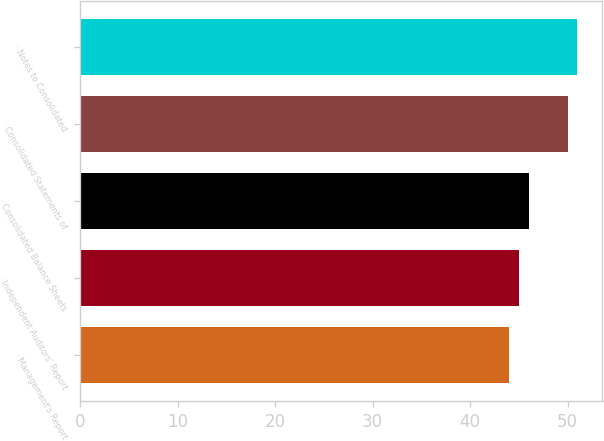Convert chart. <chart><loc_0><loc_0><loc_500><loc_500><bar_chart><fcel>· Management's Report<fcel>· Independent Auditors' Report<fcel>· Consolidated Balance Sheets<fcel>· Consolidated Statements of<fcel>· Notes to Consolidated<nl><fcel>44<fcel>45<fcel>46<fcel>50<fcel>51<nl></chart> 